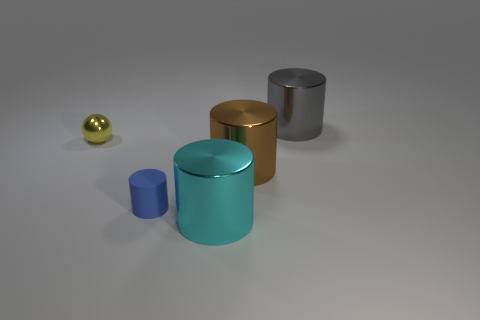Is there anything else that has the same material as the tiny blue thing?
Offer a very short reply. No. What number of blue things are rubber things or small objects?
Give a very brief answer. 1. What shape is the metal object on the left side of the big cyan shiny cylinder?
Ensure brevity in your answer.  Sphere. There is another object that is the same size as the matte object; what is its color?
Your answer should be compact. Yellow. Does the large gray thing have the same shape as the shiny thing that is in front of the tiny cylinder?
Your answer should be very brief. Yes. There is a brown object to the right of the metallic object that is on the left side of the cylinder left of the large cyan thing; what is it made of?
Make the answer very short. Metal. What number of tiny things are either balls or blue shiny cylinders?
Your answer should be compact. 1. What number of other objects are the same size as the gray object?
Ensure brevity in your answer.  2. There is a object behind the ball; is its shape the same as the small blue thing?
Offer a very short reply. Yes. What color is the other small thing that is the same shape as the cyan metallic thing?
Your answer should be compact. Blue. 